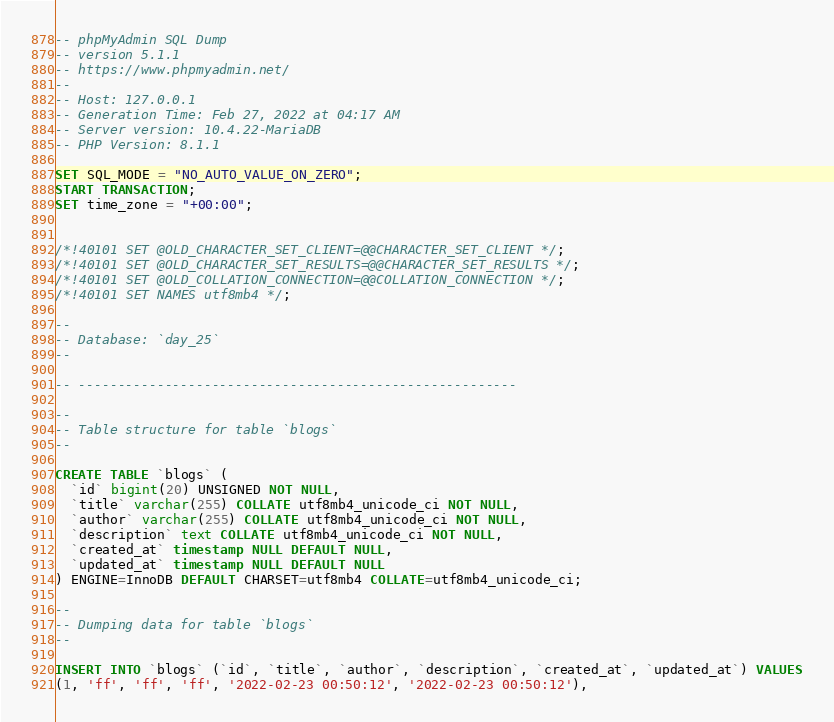<code> <loc_0><loc_0><loc_500><loc_500><_SQL_>-- phpMyAdmin SQL Dump
-- version 5.1.1
-- https://www.phpmyadmin.net/
--
-- Host: 127.0.0.1
-- Generation Time: Feb 27, 2022 at 04:17 AM
-- Server version: 10.4.22-MariaDB
-- PHP Version: 8.1.1

SET SQL_MODE = "NO_AUTO_VALUE_ON_ZERO";
START TRANSACTION;
SET time_zone = "+00:00";


/*!40101 SET @OLD_CHARACTER_SET_CLIENT=@@CHARACTER_SET_CLIENT */;
/*!40101 SET @OLD_CHARACTER_SET_RESULTS=@@CHARACTER_SET_RESULTS */;
/*!40101 SET @OLD_COLLATION_CONNECTION=@@COLLATION_CONNECTION */;
/*!40101 SET NAMES utf8mb4 */;

--
-- Database: `day_25`
--

-- --------------------------------------------------------

--
-- Table structure for table `blogs`
--

CREATE TABLE `blogs` (
  `id` bigint(20) UNSIGNED NOT NULL,
  `title` varchar(255) COLLATE utf8mb4_unicode_ci NOT NULL,
  `author` varchar(255) COLLATE utf8mb4_unicode_ci NOT NULL,
  `description` text COLLATE utf8mb4_unicode_ci NOT NULL,
  `created_at` timestamp NULL DEFAULT NULL,
  `updated_at` timestamp NULL DEFAULT NULL
) ENGINE=InnoDB DEFAULT CHARSET=utf8mb4 COLLATE=utf8mb4_unicode_ci;

--
-- Dumping data for table `blogs`
--

INSERT INTO `blogs` (`id`, `title`, `author`, `description`, `created_at`, `updated_at`) VALUES
(1, 'ff', 'ff', 'ff', '2022-02-23 00:50:12', '2022-02-23 00:50:12'),</code> 